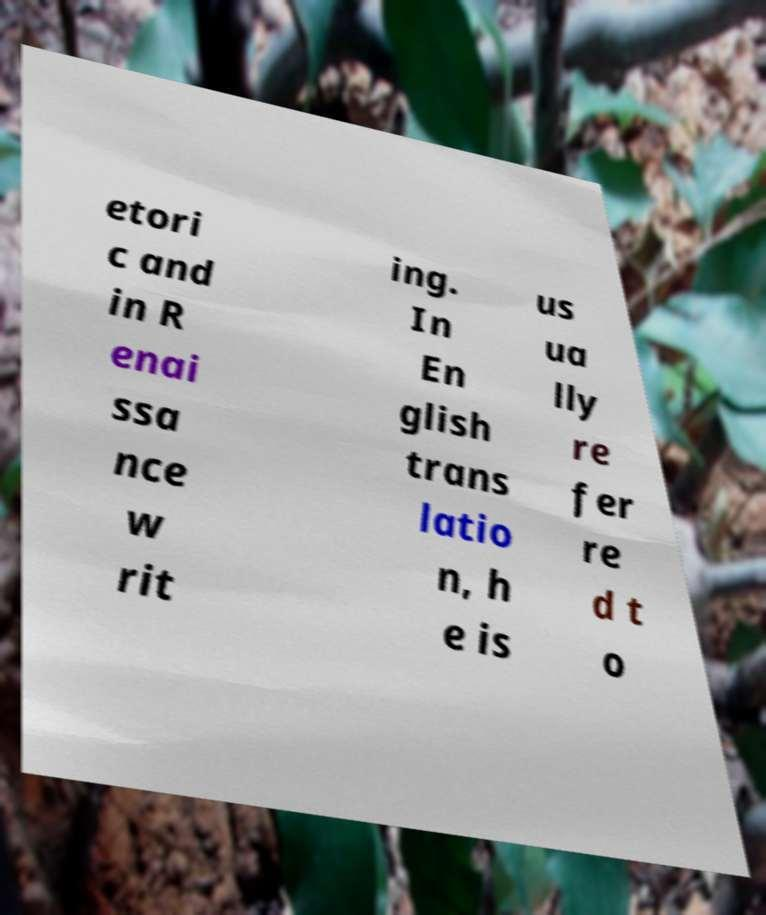What messages or text are displayed in this image? I need them in a readable, typed format. etori c and in R enai ssa nce w rit ing. In En glish trans latio n, h e is us ua lly re fer re d t o 